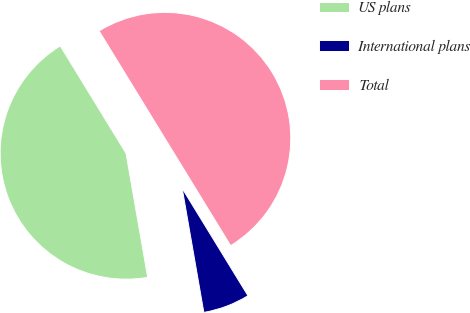Convert chart to OTSL. <chart><loc_0><loc_0><loc_500><loc_500><pie_chart><fcel>US plans<fcel>International plans<fcel>Total<nl><fcel>44.0%<fcel>6.0%<fcel>50.0%<nl></chart> 